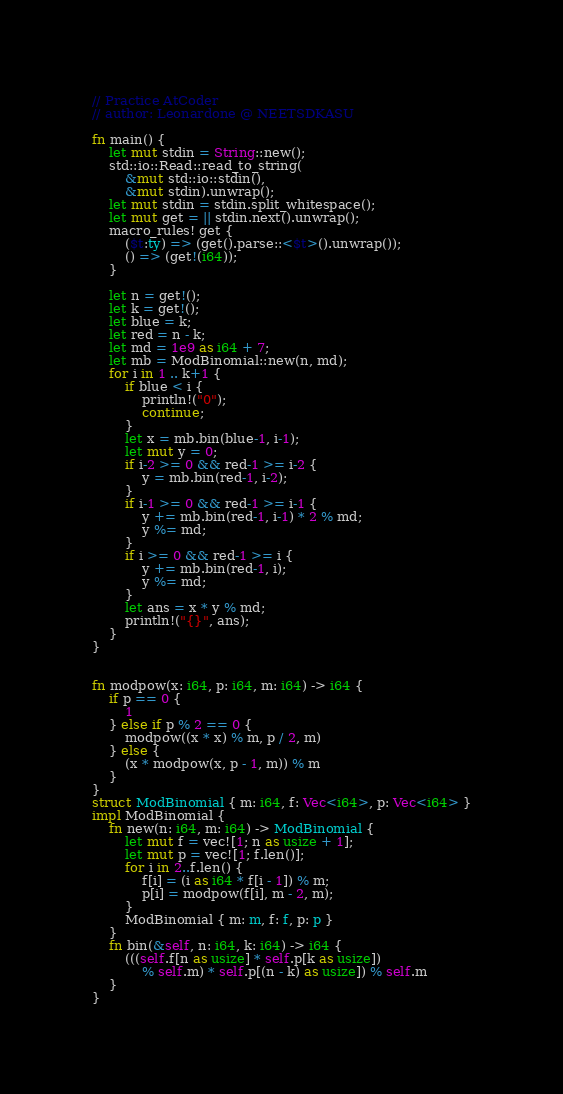Convert code to text. <code><loc_0><loc_0><loc_500><loc_500><_Rust_>// Practice AtCoder
// author: Leonardone @ NEETSDKASU

fn main() {
    let mut stdin = String::new();
    std::io::Read::read_to_string(
        &mut std::io::stdin(),
        &mut stdin).unwrap();
    let mut stdin = stdin.split_whitespace();
    let mut get = || stdin.next().unwrap();
    macro_rules! get {
        ($t:ty) => (get().parse::<$t>().unwrap());
        () => (get!(i64));
    }
    
    let n = get!();
    let k = get!();
    let blue = k;
    let red = n - k;
    let md = 1e9 as i64 + 7;
    let mb = ModBinomial::new(n, md);
    for i in 1 .. k+1 {
        if blue < i {
            println!("0");
            continue;
        }
        let x = mb.bin(blue-1, i-1);
        let mut y = 0;
        if i-2 >= 0 && red-1 >= i-2 {
            y = mb.bin(red-1, i-2);
        }
        if i-1 >= 0 && red-1 >= i-1 {
            y += mb.bin(red-1, i-1) * 2 % md;
            y %= md;
        }
        if i >= 0 && red-1 >= i {
            y += mb.bin(red-1, i);
            y %= md;
        }
        let ans = x * y % md;
        println!("{}", ans);
    }
}


fn modpow(x: i64, p: i64, m: i64) -> i64 {
    if p == 0 {
        1
    } else if p % 2 == 0 {
        modpow((x * x) % m, p / 2, m)
    } else {
        (x * modpow(x, p - 1, m)) % m 
    }
}
struct ModBinomial { m: i64, f: Vec<i64>, p: Vec<i64> }
impl ModBinomial {
    fn new(n: i64, m: i64) -> ModBinomial {
        let mut f = vec![1; n as usize + 1];
        let mut p = vec![1; f.len()];
        for i in 2..f.len() {
            f[i] = (i as i64 * f[i - 1]) % m;
            p[i] = modpow(f[i], m - 2, m);
        }
        ModBinomial { m: m, f: f, p: p }
    }
    fn bin(&self, n: i64, k: i64) -> i64 {
        (((self.f[n as usize] * self.p[k as usize])
            % self.m) * self.p[(n - k) as usize]) % self.m
    }
}
</code> 